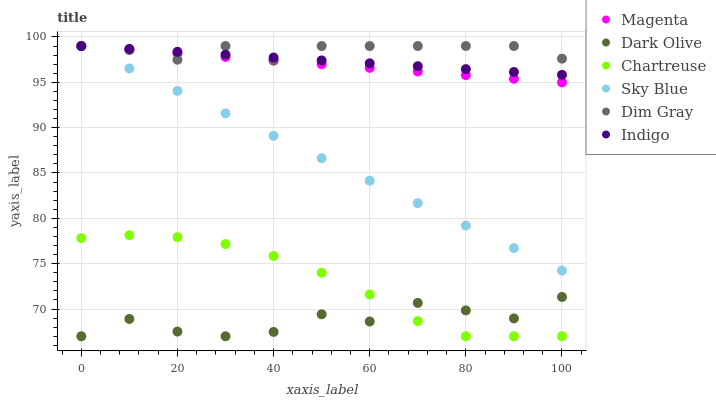Does Dark Olive have the minimum area under the curve?
Answer yes or no. Yes. Does Dim Gray have the maximum area under the curve?
Answer yes or no. Yes. Does Indigo have the minimum area under the curve?
Answer yes or no. No. Does Indigo have the maximum area under the curve?
Answer yes or no. No. Is Magenta the smoothest?
Answer yes or no. Yes. Is Dark Olive the roughest?
Answer yes or no. Yes. Is Indigo the smoothest?
Answer yes or no. No. Is Indigo the roughest?
Answer yes or no. No. Does Dark Olive have the lowest value?
Answer yes or no. Yes. Does Indigo have the lowest value?
Answer yes or no. No. Does Magenta have the highest value?
Answer yes or no. Yes. Does Dark Olive have the highest value?
Answer yes or no. No. Is Dark Olive less than Dim Gray?
Answer yes or no. Yes. Is Indigo greater than Dark Olive?
Answer yes or no. Yes. Does Dim Gray intersect Sky Blue?
Answer yes or no. Yes. Is Dim Gray less than Sky Blue?
Answer yes or no. No. Is Dim Gray greater than Sky Blue?
Answer yes or no. No. Does Dark Olive intersect Dim Gray?
Answer yes or no. No. 